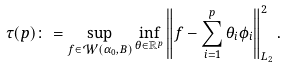Convert formula to latex. <formula><loc_0><loc_0><loc_500><loc_500>\tau ( p ) \colon = \sup _ { f \in \mathcal { W } ( \alpha _ { 0 } , B ) } \inf _ { \theta \in \mathbb { R } ^ { p } } \left \| f - \sum _ { i = 1 } ^ { p } \theta _ { i } \phi _ { i } \right \| ^ { 2 } _ { L _ { 2 } } .</formula> 